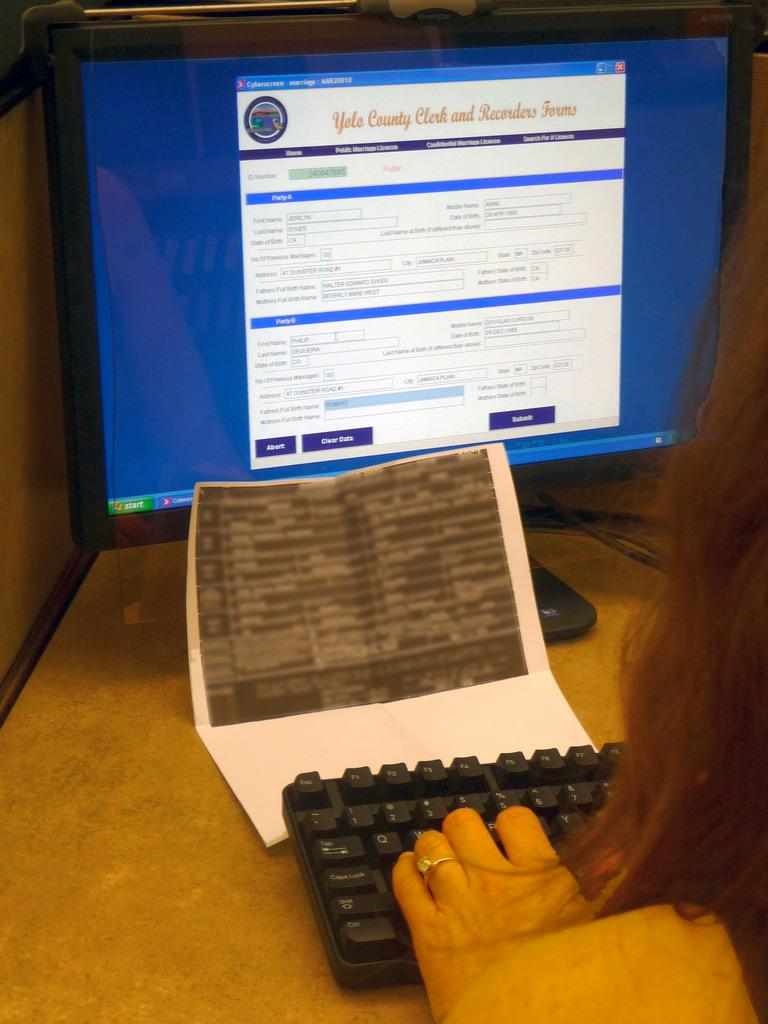What is the person in the image doing? The person is sitting in front of a desktop. Where is the desktop located? The desktop is placed on a table. What else can be seen on the table? There is a paper on the table. What type of paste is being used to connect the cables in the image? There is no paste or cables present in the image; it only shows a person sitting in front of a desktop and a paper on the table. 